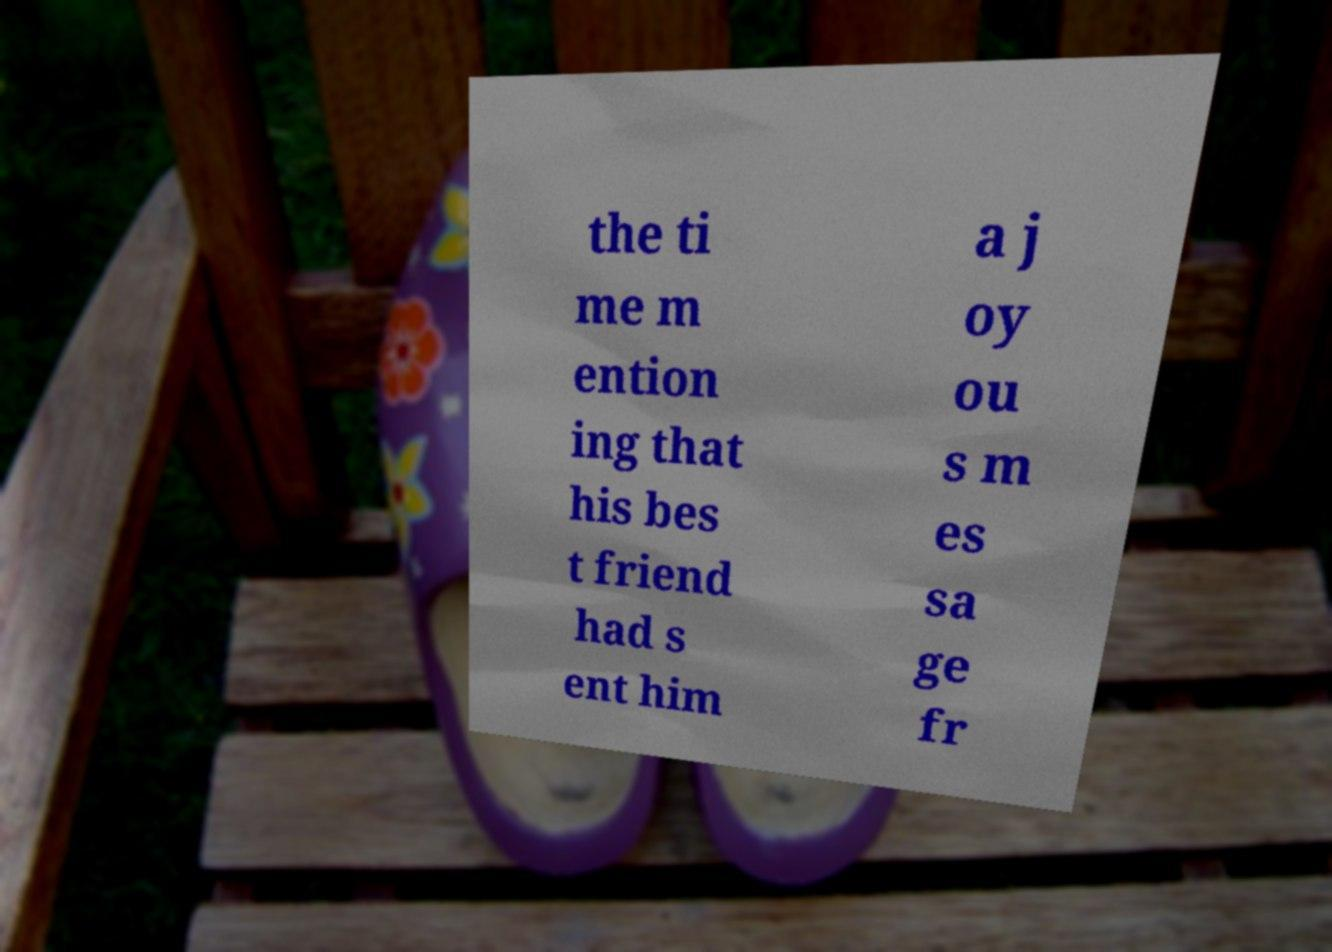Can you accurately transcribe the text from the provided image for me? the ti me m ention ing that his bes t friend had s ent him a j oy ou s m es sa ge fr 